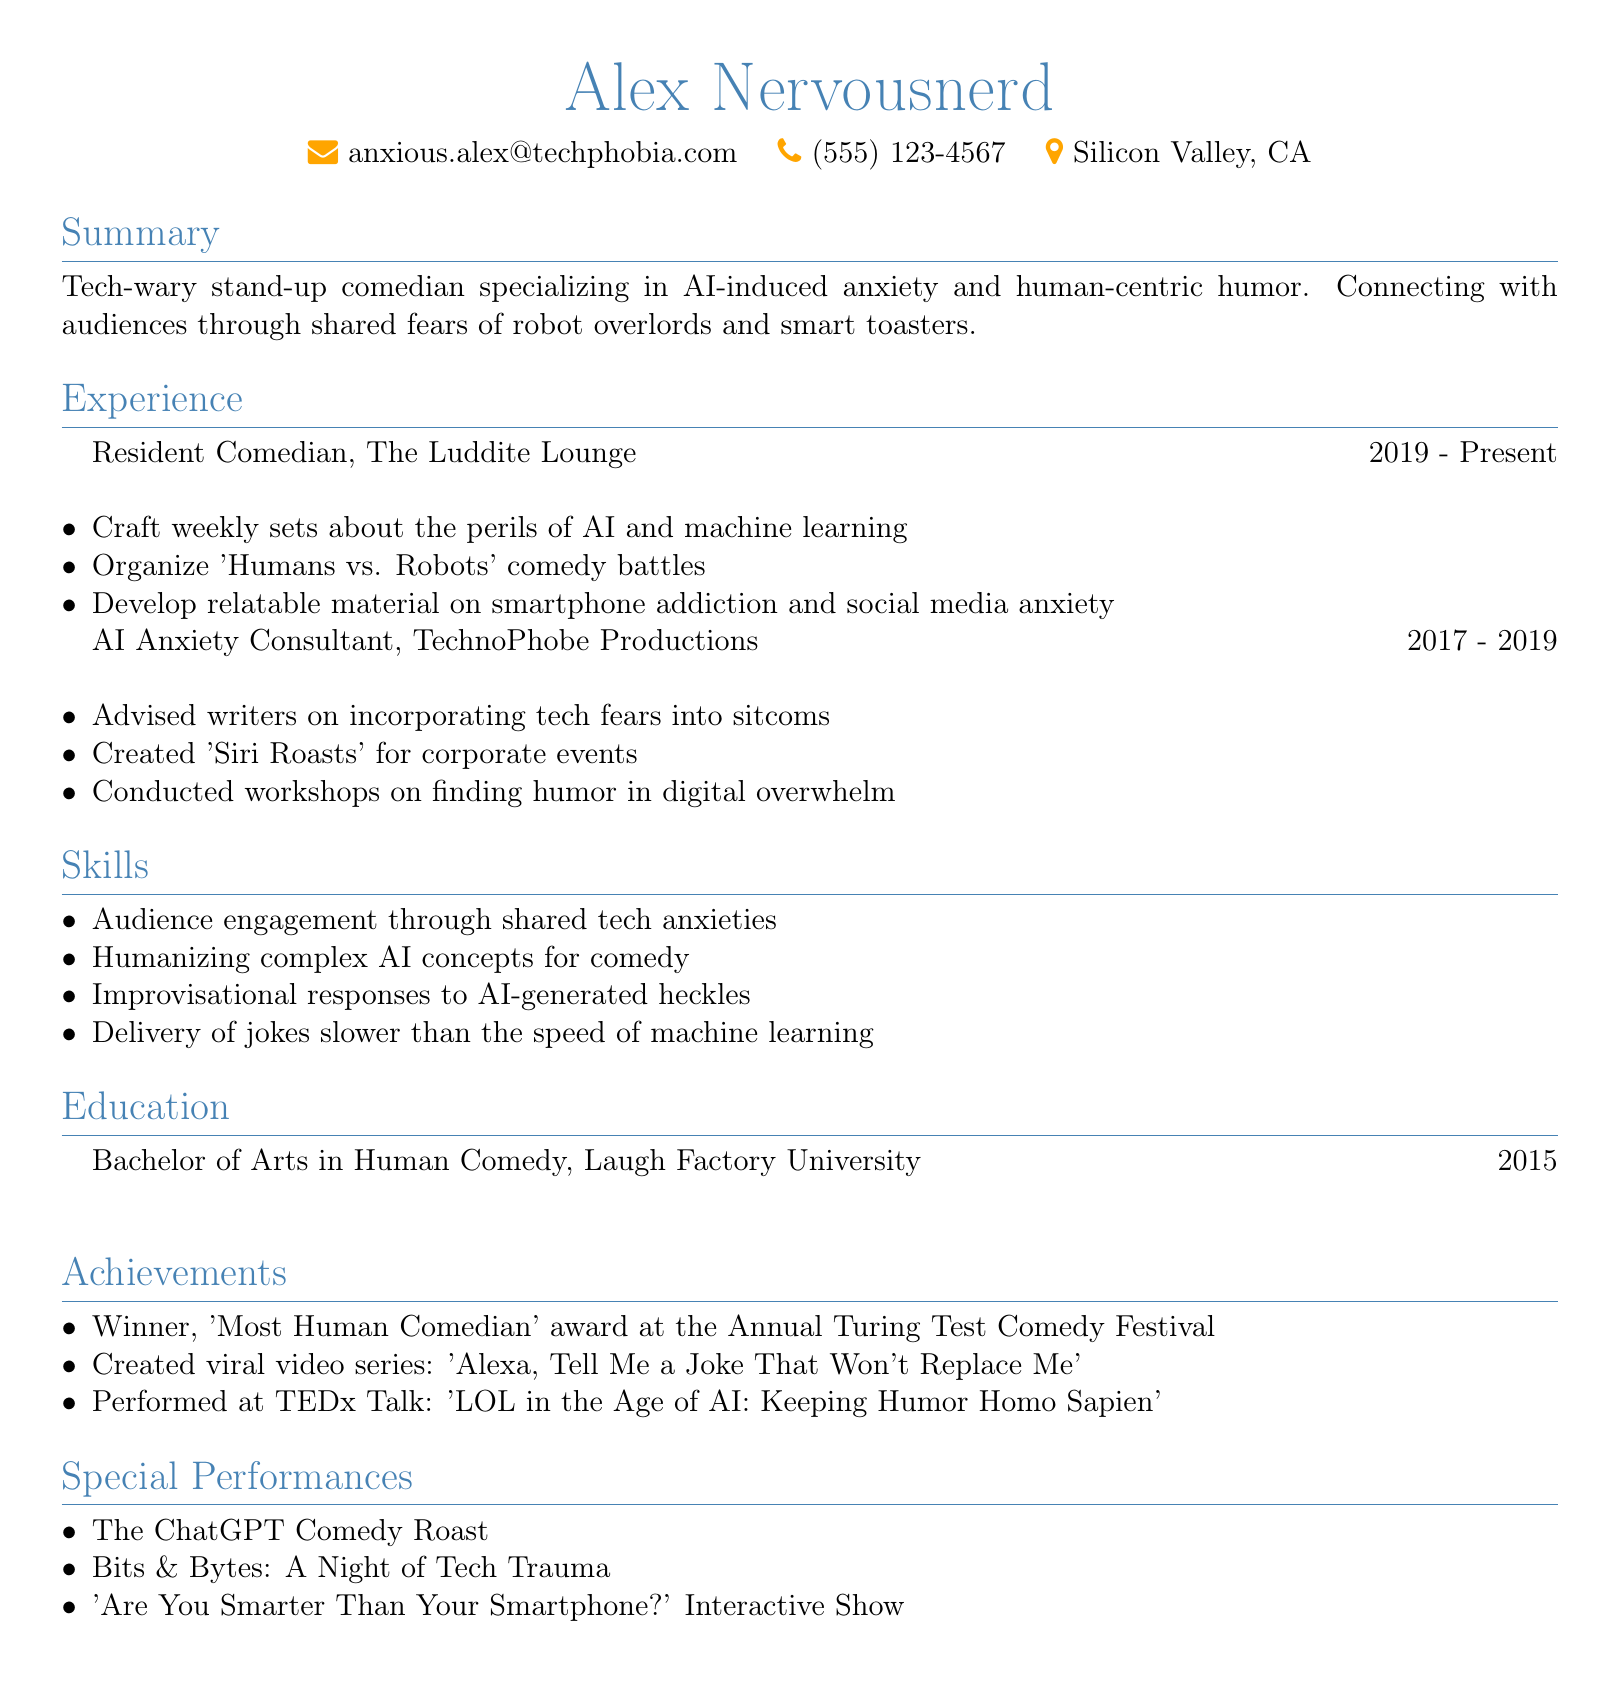What is the name of the comedian? The document states the comedian's name as Alex Nervousnerd.
Answer: Alex Nervousnerd What is the email address listed? The email address shown in the document is anxious.alex@techphobia.com.
Answer: anxious.alex@techphobia.com When did Alex start working at The Luddite Lounge? The document indicates that Alex began working at The Luddite Lounge in 2019.
Answer: 2019 What is one of the responsibilities at TechnoPhobe Productions? The document lists advising writers on incorporating tech fears into sitcoms as a responsibility.
Answer: Advised writers on incorporating tech fears into sitcoms What award did Alex win? The document states that Alex won the 'Most Human Comedian' award.
Answer: Most Human Comedian What is the degree obtained by Alex? According to the document, Alex holds a Bachelor of Arts in Human Comedy.
Answer: Bachelor of Arts in Human Comedy What kind of workshops did Alex conduct? The document mentions conducting workshops on finding humor in digital overwhelm.
Answer: Workshops on finding humor in digital overwhelm Name one special performance listed. The document provides 'The ChatGPT Comedy Roast' as one of the special performances.
Answer: The ChatGPT Comedy Roast 